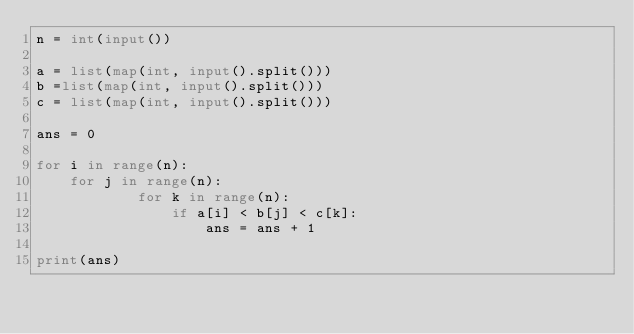Convert code to text. <code><loc_0><loc_0><loc_500><loc_500><_Python_>n = int(input())

a = list(map(int, input().split()))
b =list(map(int, input().split()))
c = list(map(int, input().split()))

ans = 0

for i in range(n):
    for j in range(n):
            for k in range(n):
                if a[i] < b[j] < c[k]:
                    ans = ans + 1

print(ans)
    </code> 